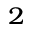<formula> <loc_0><loc_0><loc_500><loc_500>_ { 2 }</formula> 